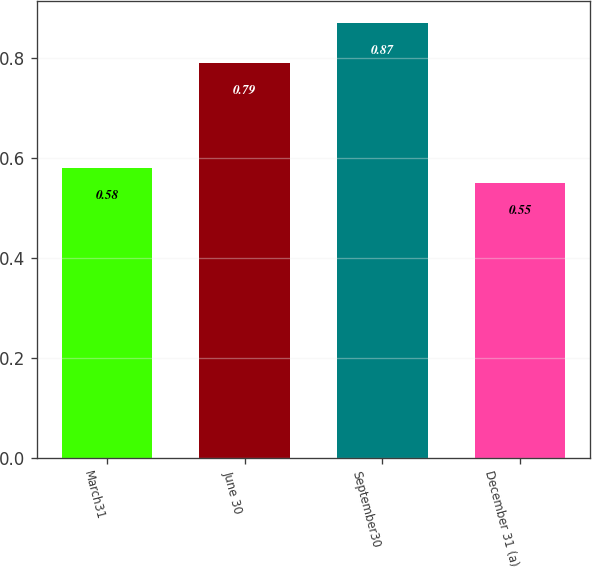<chart> <loc_0><loc_0><loc_500><loc_500><bar_chart><fcel>March31<fcel>June 30<fcel>September30<fcel>December 31 (a)<nl><fcel>0.58<fcel>0.79<fcel>0.87<fcel>0.55<nl></chart> 